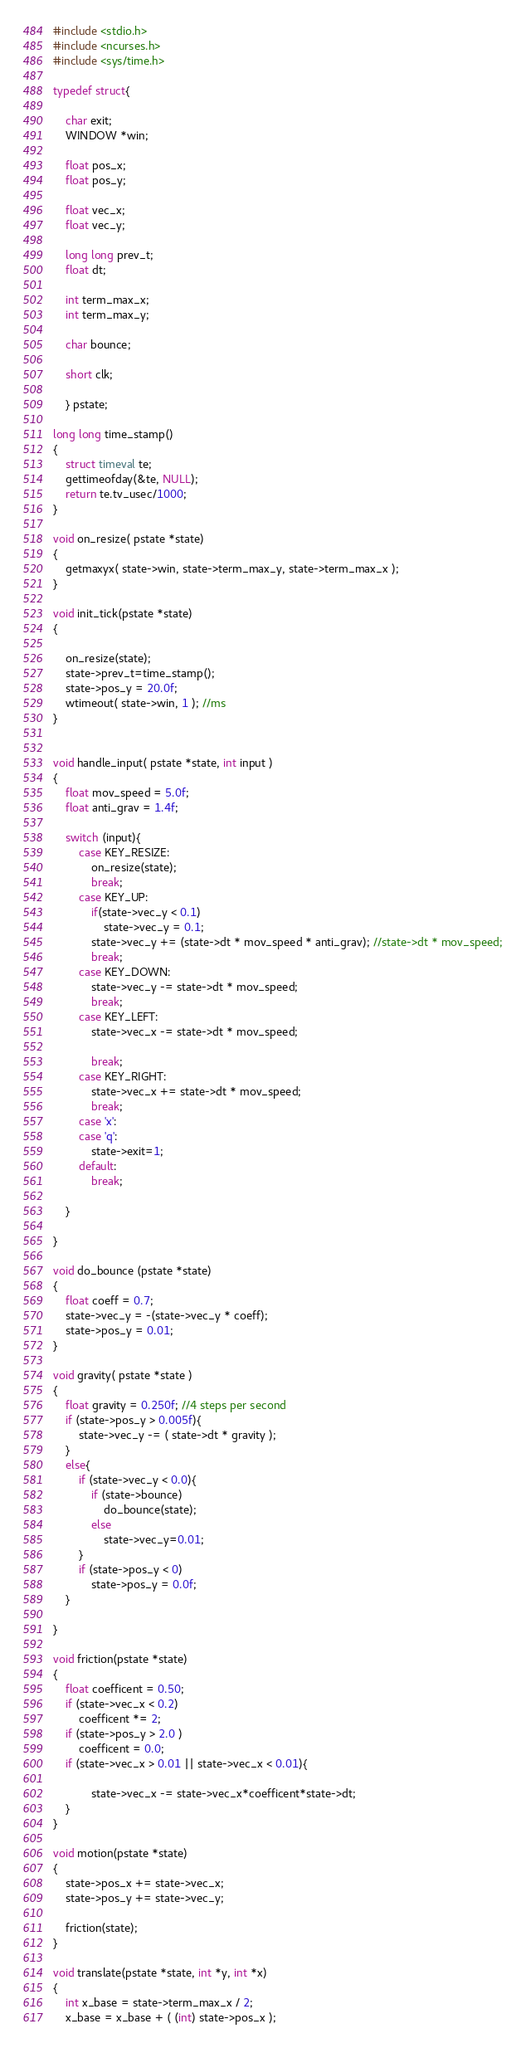<code> <loc_0><loc_0><loc_500><loc_500><_C_>#include <stdio.h>
#include <ncurses.h>
#include <sys/time.h>

typedef struct{

    char exit;
    WINDOW *win;

    float pos_x;
    float pos_y;

    float vec_x;
    float vec_y;

    long long prev_t;
    float dt;

    int term_max_x;
    int term_max_y;

    char bounce;

    short clk;

    } pstate;

long long time_stamp() 
{ 
    struct timeval te;
    gettimeofday(&te, NULL);
    return te.tv_usec/1000;
}

void on_resize( pstate *state)
{
    getmaxyx( state->win, state->term_max_y, state->term_max_x );
}

void init_tick(pstate *state)
{
    
    on_resize(state);
    state->prev_t=time_stamp();
    state->pos_y = 20.0f;
    wtimeout( state->win, 1 ); //ms
}


void handle_input( pstate *state, int input )
{
    float mov_speed = 5.0f;
    float anti_grav = 1.4f;

    switch (input){
        case KEY_RESIZE:
            on_resize(state);
            break;
        case KEY_UP:
            if(state->vec_y < 0.1)
                state->vec_y = 0.1;
            state->vec_y += (state->dt * mov_speed * anti_grav); //state->dt * mov_speed;
            break;
        case KEY_DOWN:
            state->vec_y -= state->dt * mov_speed;
            break;
        case KEY_LEFT:
            state->vec_x -= state->dt * mov_speed;

            break;
        case KEY_RIGHT:
            state->vec_x += state->dt * mov_speed;
            break;
        case 'x':
        case 'q':
            state->exit=1;
        default:
            break;

    }
    
}

void do_bounce (pstate *state)
{
    float coeff = 0.7;
    state->vec_y = -(state->vec_y * coeff);
    state->pos_y = 0.01;
}

void gravity( pstate *state )
{
    float gravity = 0.250f; //4 steps per second
    if (state->pos_y > 0.005f){
        state->vec_y -= ( state->dt * gravity );
    }
    else{
        if (state->vec_y < 0.0){
            if (state->bounce)
                do_bounce(state);
            else
                state->vec_y=0.01;
        }
        if (state->pos_y < 0)
            state->pos_y = 0.0f;
    }

}

void friction(pstate *state)
{
    float coefficent = 0.50;
    if (state->vec_x < 0.2)
        coefficent *= 2;
    if (state->pos_y > 2.0 )
        coefficent = 0.0;
    if (state->vec_x > 0.01 || state->vec_x < 0.01){

            state->vec_x -= state->vec_x*coefficent*state->dt;
    }
}

void motion(pstate *state)
{
    state->pos_x += state->vec_x;
    state->pos_y += state->vec_y;

    friction(state);
}

void translate(pstate *state, int *y, int *x)
{
    int x_base = state->term_max_x / 2;
    x_base = x_base + ( (int) state->pos_x );</code> 